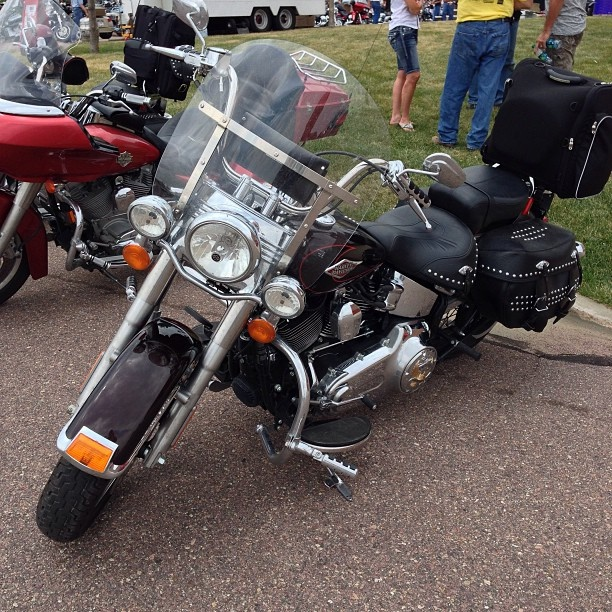Describe the objects in this image and their specific colors. I can see motorcycle in gray, black, darkgray, and lightgray tones, motorcycle in gray, black, maroon, and lightgray tones, suitcase in gray, black, and darkgray tones, people in gray, navy, darkblue, black, and khaki tones, and suitcase in gray, black, and darkgray tones in this image. 